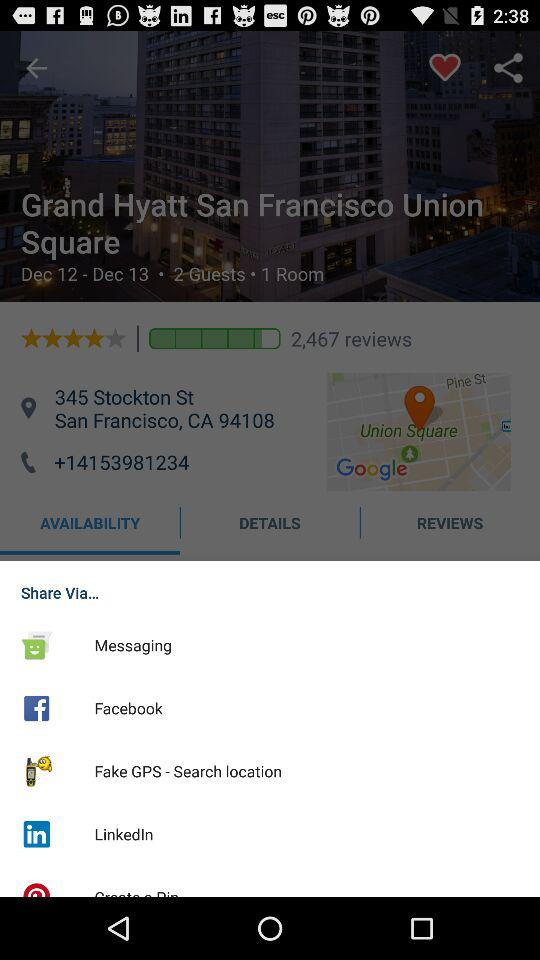How many reviews does the hotel have?
Answer the question using a single word or phrase. 2,467 